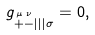Convert formula to latex. <formula><loc_0><loc_0><loc_500><loc_500>g _ { \stackrel { \mu } { + } \stackrel { \nu } { - } | | | \sigma } = 0 ,</formula> 